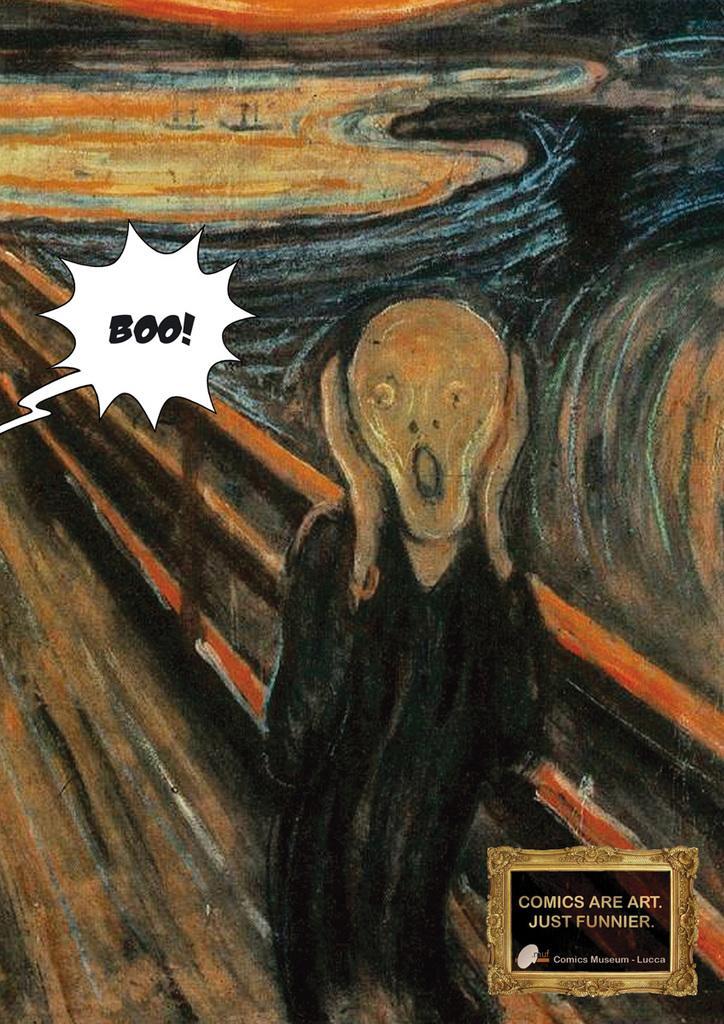How would you summarize this image in a sentence or two? In this picture we can see a painting. There is a watermark on the right side. 